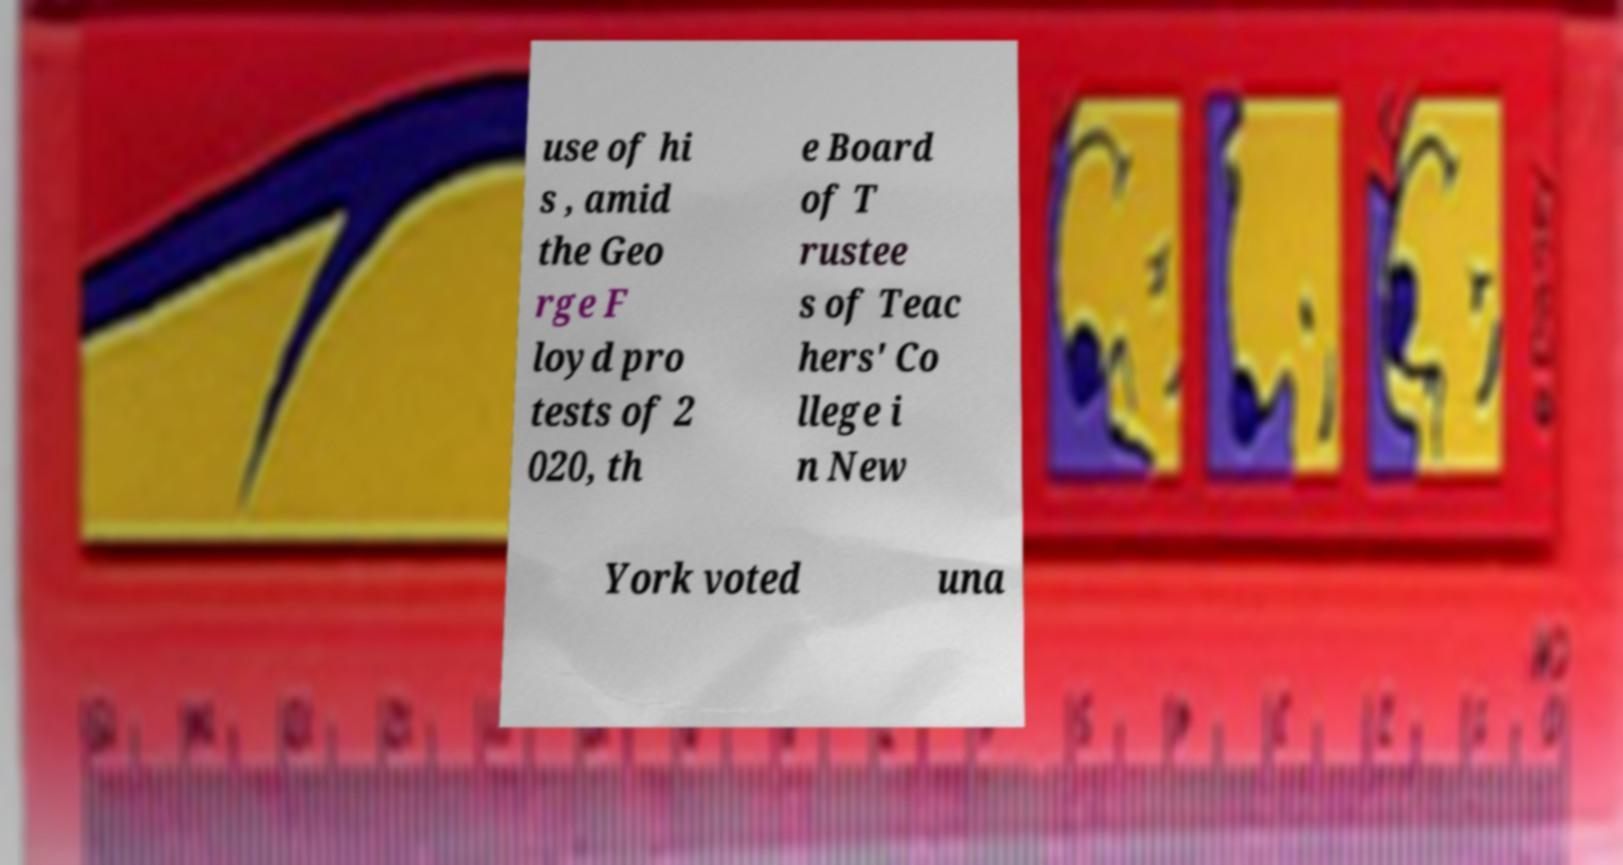Could you extract and type out the text from this image? use of hi s , amid the Geo rge F loyd pro tests of 2 020, th e Board of T rustee s of Teac hers' Co llege i n New York voted una 